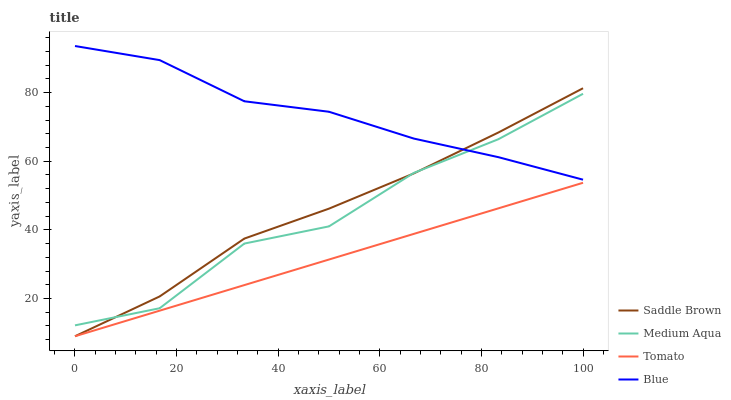Does Medium Aqua have the minimum area under the curve?
Answer yes or no. No. Does Medium Aqua have the maximum area under the curve?
Answer yes or no. No. Is Blue the smoothest?
Answer yes or no. No. Is Blue the roughest?
Answer yes or no. No. Does Medium Aqua have the lowest value?
Answer yes or no. No. Does Medium Aqua have the highest value?
Answer yes or no. No. Is Tomato less than Blue?
Answer yes or no. Yes. Is Medium Aqua greater than Tomato?
Answer yes or no. Yes. Does Tomato intersect Blue?
Answer yes or no. No. 